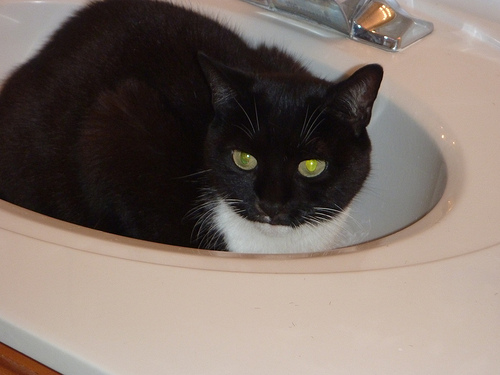How many cats are seen? 1 